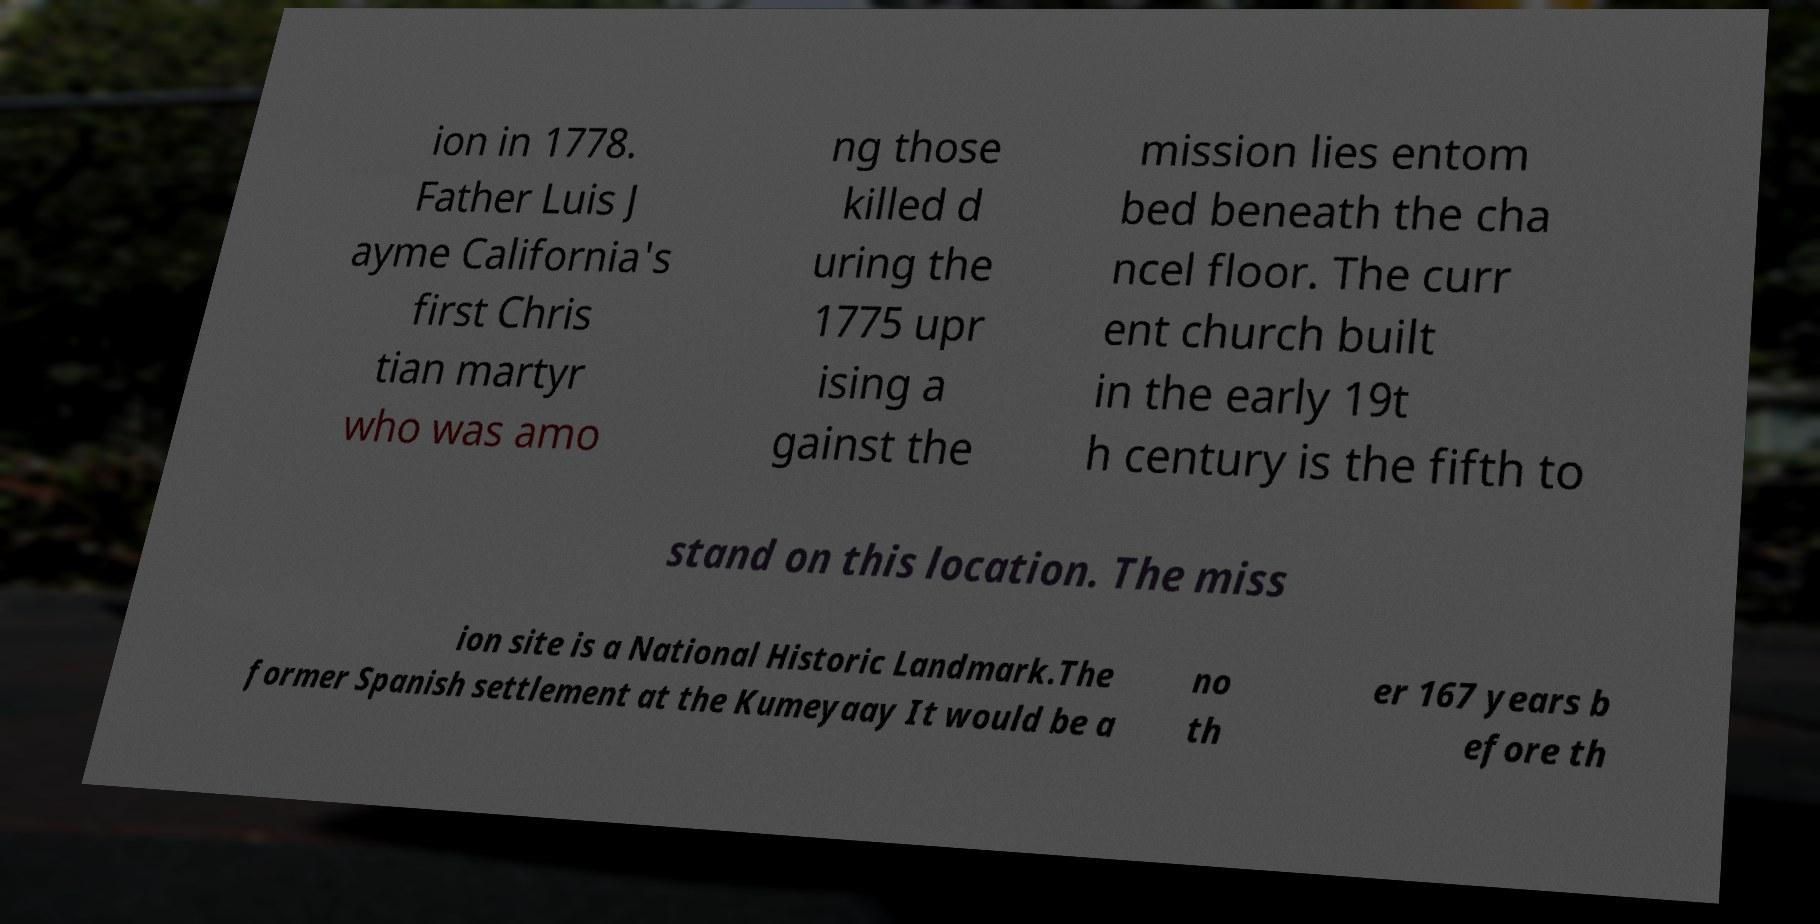Please read and relay the text visible in this image. What does it say? ion in 1778. Father Luis J ayme California's first Chris tian martyr who was amo ng those killed d uring the 1775 upr ising a gainst the mission lies entom bed beneath the cha ncel floor. The curr ent church built in the early 19t h century is the fifth to stand on this location. The miss ion site is a National Historic Landmark.The former Spanish settlement at the Kumeyaay It would be a no th er 167 years b efore th 